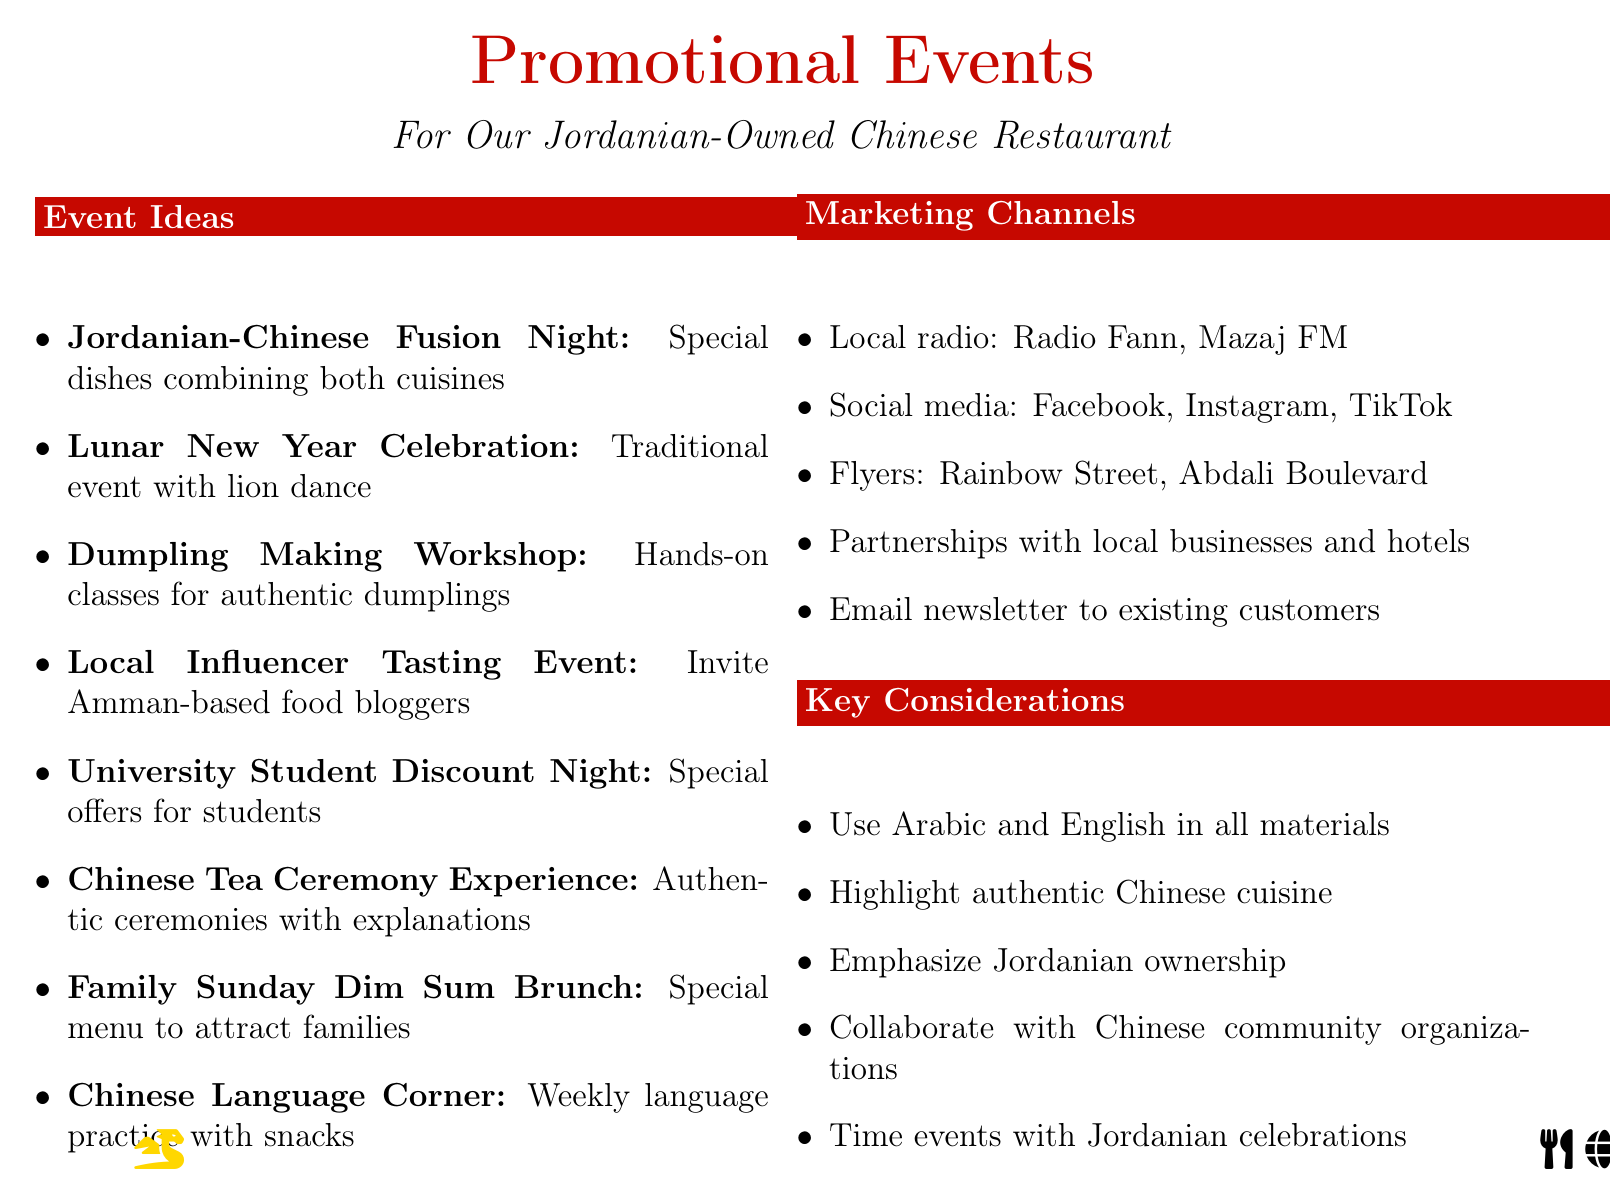What is the name of the event that combines Jordanian and Chinese cuisines? The name of the event that showcases special dishes combining both cuisines is mentioned in the document.
Answer: Jordanian-Chinese Fusion Night What type of audience is targeted by the Lunar New Year Celebration? The document specifies the target audience for the Lunar New Year event.
Answer: Families and cultural enthusiasts Which marketing channel involves local radio stations? The document lists specific channels for marketing, including local radio.
Answer: Local radio stations like Radio Fann and Mazaj FM What is the purpose of the Dumpling Making Workshop? The document describes the Dumpling Making Workshop focusing on customer engagement.
Answer: Teaching customers how to make authentic Chinese dumplings How many promotional events are listed in the document? The total number of promotional events is indicated in the list within the document.
Answer: Eight What is the target audience for the University Student Discount Night? The document states the specific audience this event is aimed at.
Answer: College students and young adults What is a key consideration mentioned for promotional materials? The document highlights an important guideline for the creation of promotional content.
Answer: Ensure all promotional materials are in both Arabic and English What type of event is the Family Sunday Dim Sum Brunch? The document provides a context for this specific event in its description.
Answer: A special dim sum brunch menu on Sundays to attract families 